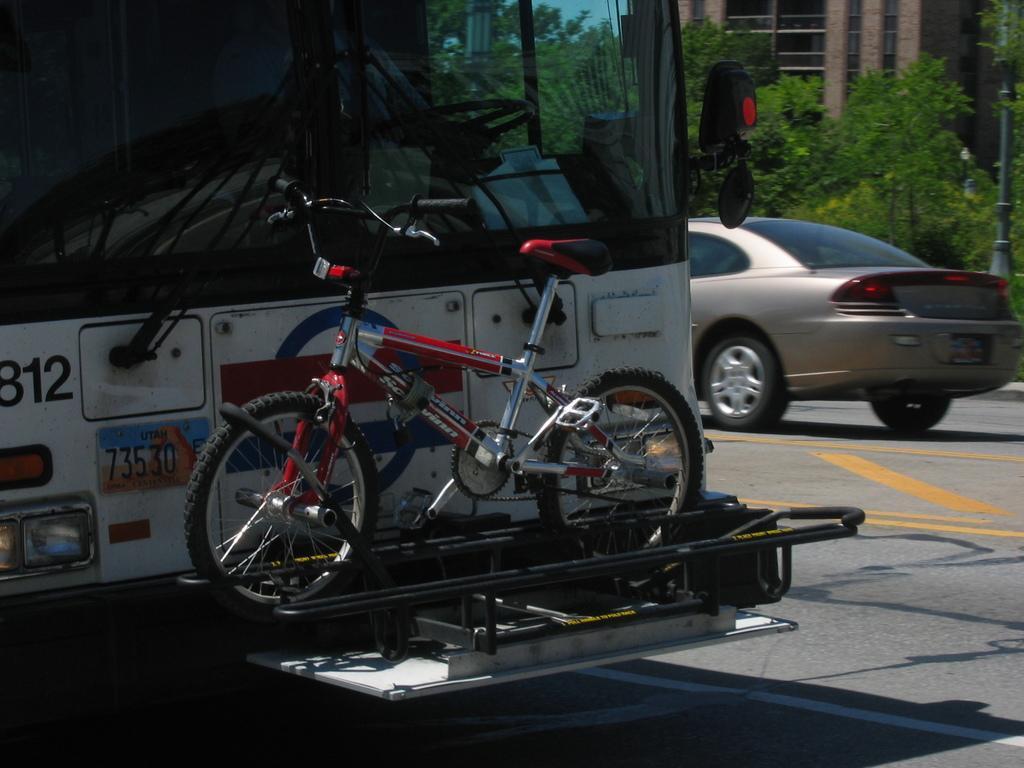Describe this image in one or two sentences. As we can see in the image there is a truck, bicycle, car, trees and building. 